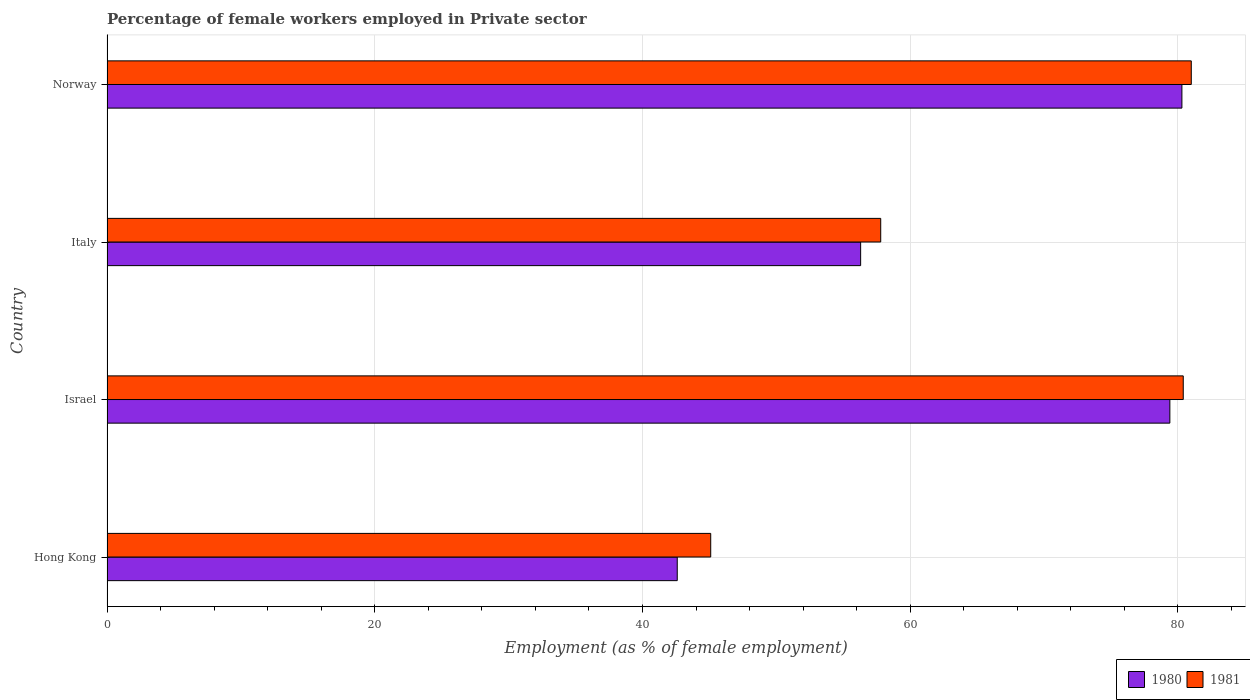How many groups of bars are there?
Your response must be concise. 4. Are the number of bars per tick equal to the number of legend labels?
Your response must be concise. Yes. How many bars are there on the 3rd tick from the top?
Offer a very short reply. 2. What is the label of the 2nd group of bars from the top?
Offer a very short reply. Italy. In how many cases, is the number of bars for a given country not equal to the number of legend labels?
Provide a succinct answer. 0. Across all countries, what is the maximum percentage of females employed in Private sector in 1981?
Give a very brief answer. 81. Across all countries, what is the minimum percentage of females employed in Private sector in 1980?
Your answer should be compact. 42.6. In which country was the percentage of females employed in Private sector in 1980 maximum?
Your answer should be very brief. Norway. In which country was the percentage of females employed in Private sector in 1981 minimum?
Ensure brevity in your answer.  Hong Kong. What is the total percentage of females employed in Private sector in 1980 in the graph?
Make the answer very short. 258.6. What is the difference between the percentage of females employed in Private sector in 1980 in Israel and that in Italy?
Give a very brief answer. 23.1. What is the difference between the percentage of females employed in Private sector in 1981 in Hong Kong and the percentage of females employed in Private sector in 1980 in Italy?
Offer a very short reply. -11.2. What is the average percentage of females employed in Private sector in 1980 per country?
Offer a very short reply. 64.65. What is the ratio of the percentage of females employed in Private sector in 1981 in Italy to that in Norway?
Your answer should be compact. 0.71. What is the difference between the highest and the second highest percentage of females employed in Private sector in 1981?
Make the answer very short. 0.6. What is the difference between the highest and the lowest percentage of females employed in Private sector in 1981?
Keep it short and to the point. 35.9. What does the 2nd bar from the bottom in Italy represents?
Offer a terse response. 1981. How many bars are there?
Provide a short and direct response. 8. How many countries are there in the graph?
Ensure brevity in your answer.  4. Does the graph contain any zero values?
Offer a very short reply. No. Does the graph contain grids?
Provide a succinct answer. Yes. What is the title of the graph?
Give a very brief answer. Percentage of female workers employed in Private sector. Does "1965" appear as one of the legend labels in the graph?
Give a very brief answer. No. What is the label or title of the X-axis?
Provide a succinct answer. Employment (as % of female employment). What is the label or title of the Y-axis?
Ensure brevity in your answer.  Country. What is the Employment (as % of female employment) in 1980 in Hong Kong?
Ensure brevity in your answer.  42.6. What is the Employment (as % of female employment) in 1981 in Hong Kong?
Offer a very short reply. 45.1. What is the Employment (as % of female employment) of 1980 in Israel?
Provide a succinct answer. 79.4. What is the Employment (as % of female employment) of 1981 in Israel?
Your answer should be compact. 80.4. What is the Employment (as % of female employment) in 1980 in Italy?
Ensure brevity in your answer.  56.3. What is the Employment (as % of female employment) in 1981 in Italy?
Give a very brief answer. 57.8. What is the Employment (as % of female employment) in 1980 in Norway?
Provide a short and direct response. 80.3. Across all countries, what is the maximum Employment (as % of female employment) of 1980?
Provide a succinct answer. 80.3. Across all countries, what is the maximum Employment (as % of female employment) in 1981?
Keep it short and to the point. 81. Across all countries, what is the minimum Employment (as % of female employment) of 1980?
Make the answer very short. 42.6. Across all countries, what is the minimum Employment (as % of female employment) in 1981?
Provide a succinct answer. 45.1. What is the total Employment (as % of female employment) in 1980 in the graph?
Ensure brevity in your answer.  258.6. What is the total Employment (as % of female employment) in 1981 in the graph?
Make the answer very short. 264.3. What is the difference between the Employment (as % of female employment) in 1980 in Hong Kong and that in Israel?
Your answer should be very brief. -36.8. What is the difference between the Employment (as % of female employment) of 1981 in Hong Kong and that in Israel?
Ensure brevity in your answer.  -35.3. What is the difference between the Employment (as % of female employment) in 1980 in Hong Kong and that in Italy?
Offer a terse response. -13.7. What is the difference between the Employment (as % of female employment) of 1981 in Hong Kong and that in Italy?
Provide a short and direct response. -12.7. What is the difference between the Employment (as % of female employment) of 1980 in Hong Kong and that in Norway?
Make the answer very short. -37.7. What is the difference between the Employment (as % of female employment) of 1981 in Hong Kong and that in Norway?
Offer a terse response. -35.9. What is the difference between the Employment (as % of female employment) in 1980 in Israel and that in Italy?
Make the answer very short. 23.1. What is the difference between the Employment (as % of female employment) of 1981 in Israel and that in Italy?
Provide a short and direct response. 22.6. What is the difference between the Employment (as % of female employment) of 1981 in Italy and that in Norway?
Provide a short and direct response. -23.2. What is the difference between the Employment (as % of female employment) in 1980 in Hong Kong and the Employment (as % of female employment) in 1981 in Israel?
Offer a very short reply. -37.8. What is the difference between the Employment (as % of female employment) of 1980 in Hong Kong and the Employment (as % of female employment) of 1981 in Italy?
Provide a succinct answer. -15.2. What is the difference between the Employment (as % of female employment) of 1980 in Hong Kong and the Employment (as % of female employment) of 1981 in Norway?
Provide a succinct answer. -38.4. What is the difference between the Employment (as % of female employment) of 1980 in Israel and the Employment (as % of female employment) of 1981 in Italy?
Your answer should be very brief. 21.6. What is the difference between the Employment (as % of female employment) in 1980 in Israel and the Employment (as % of female employment) in 1981 in Norway?
Keep it short and to the point. -1.6. What is the difference between the Employment (as % of female employment) of 1980 in Italy and the Employment (as % of female employment) of 1981 in Norway?
Ensure brevity in your answer.  -24.7. What is the average Employment (as % of female employment) in 1980 per country?
Provide a succinct answer. 64.65. What is the average Employment (as % of female employment) in 1981 per country?
Your answer should be compact. 66.08. What is the difference between the Employment (as % of female employment) of 1980 and Employment (as % of female employment) of 1981 in Hong Kong?
Provide a short and direct response. -2.5. What is the difference between the Employment (as % of female employment) of 1980 and Employment (as % of female employment) of 1981 in Israel?
Offer a terse response. -1. What is the ratio of the Employment (as % of female employment) of 1980 in Hong Kong to that in Israel?
Your response must be concise. 0.54. What is the ratio of the Employment (as % of female employment) of 1981 in Hong Kong to that in Israel?
Your answer should be very brief. 0.56. What is the ratio of the Employment (as % of female employment) of 1980 in Hong Kong to that in Italy?
Your answer should be very brief. 0.76. What is the ratio of the Employment (as % of female employment) of 1981 in Hong Kong to that in Italy?
Keep it short and to the point. 0.78. What is the ratio of the Employment (as % of female employment) of 1980 in Hong Kong to that in Norway?
Ensure brevity in your answer.  0.53. What is the ratio of the Employment (as % of female employment) in 1981 in Hong Kong to that in Norway?
Your answer should be very brief. 0.56. What is the ratio of the Employment (as % of female employment) of 1980 in Israel to that in Italy?
Offer a very short reply. 1.41. What is the ratio of the Employment (as % of female employment) of 1981 in Israel to that in Italy?
Your answer should be very brief. 1.39. What is the ratio of the Employment (as % of female employment) in 1980 in Israel to that in Norway?
Your answer should be very brief. 0.99. What is the ratio of the Employment (as % of female employment) of 1980 in Italy to that in Norway?
Offer a very short reply. 0.7. What is the ratio of the Employment (as % of female employment) in 1981 in Italy to that in Norway?
Offer a terse response. 0.71. What is the difference between the highest and the second highest Employment (as % of female employment) of 1981?
Your response must be concise. 0.6. What is the difference between the highest and the lowest Employment (as % of female employment) of 1980?
Give a very brief answer. 37.7. What is the difference between the highest and the lowest Employment (as % of female employment) in 1981?
Give a very brief answer. 35.9. 